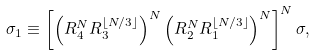Convert formula to latex. <formula><loc_0><loc_0><loc_500><loc_500>\sigma _ { 1 } \equiv \left [ \left ( R _ { 4 } ^ { N } R _ { 3 } ^ { \lfloor N / 3 \rfloor } \right ) ^ { N } \left ( R _ { 2 } ^ { N } R _ { 1 } ^ { \lfloor N / 3 \rfloor } \right ) ^ { N } \right ] ^ { N } \sigma ,</formula> 